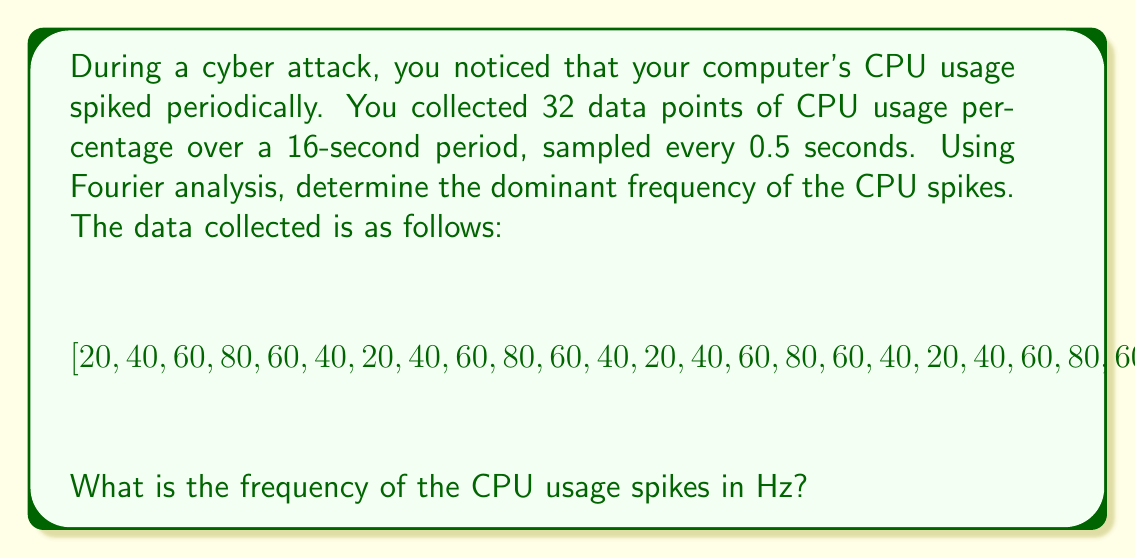Provide a solution to this math problem. To solve this problem using Fourier analysis, we'll follow these steps:

1) First, let's identify the key parameters:
   - Number of samples: $N = 32$
   - Total time period: $T = 16$ seconds
   - Sampling rate: $f_s = \frac{N}{T} = \frac{32}{16} = 2$ Hz

2) We need to compute the Discrete Fourier Transform (DFT) of the data. The DFT is given by:

   $$X_k = \sum_{n=0}^{N-1} x_n e^{-i2\pi kn/N}$$

   where $x_n$ are the input samples and $X_k$ are the frequency components.

3) In practice, we would use a Fast Fourier Transform (FFT) algorithm to compute this efficiently. The magnitude of the resulting complex numbers gives us the amplitude of each frequency component.

4) After computing the FFT, we need to find the index $k$ with the maximum amplitude (excluding $k=0$, which represents the DC component).

5) Once we have the index $k$, we can calculate the frequency using:

   $$f = k \cdot \frac{f_s}{N} = k \cdot \frac{2}{32} = \frac{k}{16}$$

6) Looking at the data, we can see that it repeats every 6 samples. This suggests that the dominant frequency will be:

   $$f = \frac{1}{6 \cdot 0.5} = \frac{1}{3} \approx 0.333 \text{ Hz}$$

7) This corresponds to $k = 5$ in our FFT output (as $\frac{5}{16} \approx 0.3125$, which is the closest frequency bin to $\frac{1}{3}$).

Therefore, the dominant frequency of the CPU usage spikes is approximately $\frac{1}{3}$ Hz.
Answer: $\frac{1}{3}$ Hz (approximately 0.333 Hz) 